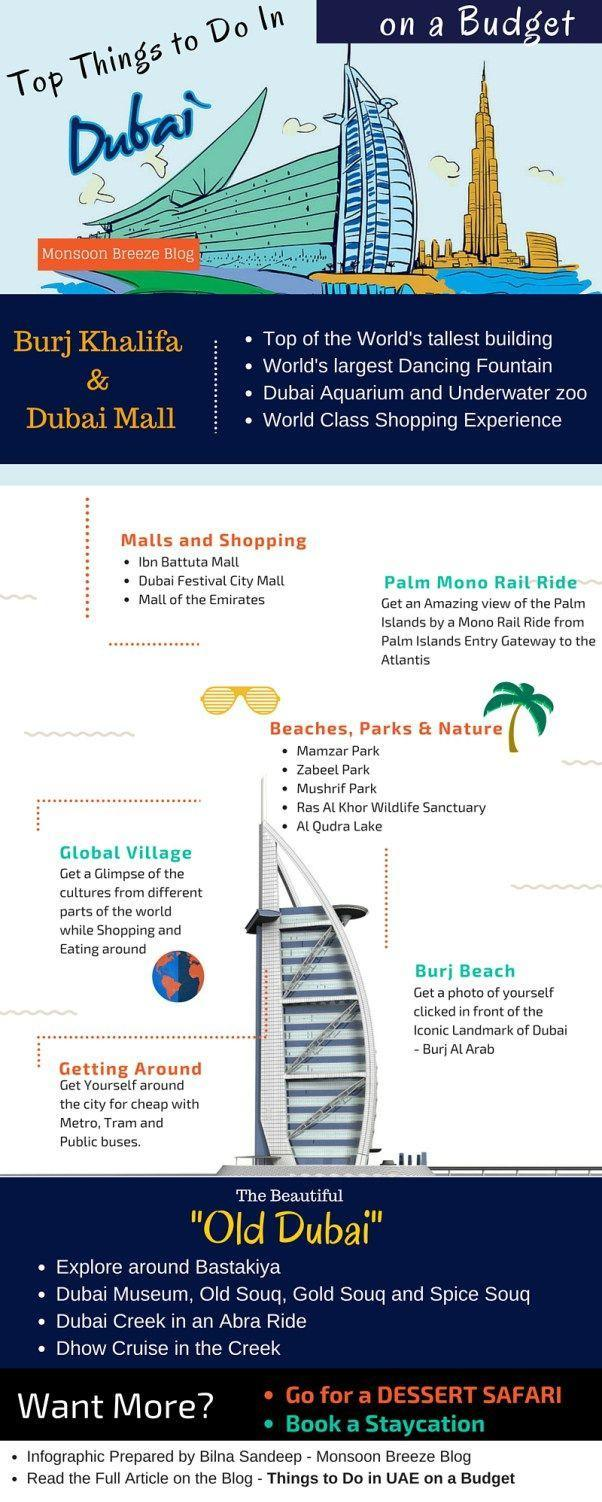how many souqs are mentioned
Answer the question with a short phrase. 3 which the world's tallest building burj khalifa where is bastakiya old dubai which are the modes of transport metro, tram and public bises where is the world's largest dancing fountain dubai mall how many malls have been mentioned here 4 